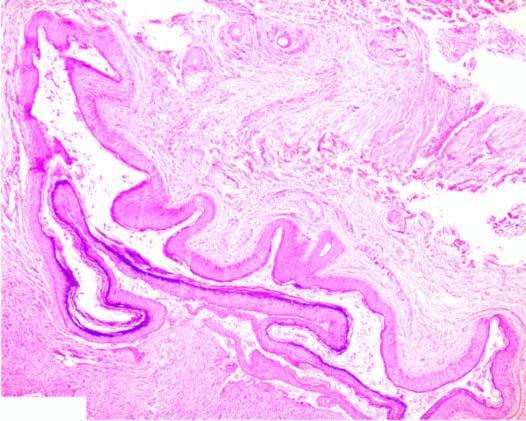what has adnexal structures in the cyst wall ie in addition to features of epidermal cyst?
Answer the question using a single word or phrase. In cyst 